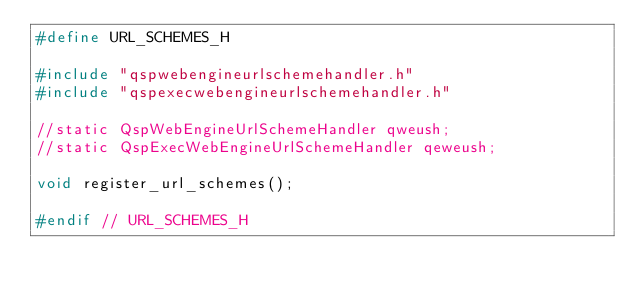<code> <loc_0><loc_0><loc_500><loc_500><_C_>#define URL_SCHEMES_H

#include "qspwebengineurlschemehandler.h"
#include "qspexecwebengineurlschemehandler.h"

//static QspWebEngineUrlSchemeHandler qweush;
//static QspExecWebEngineUrlSchemeHandler qeweush;

void register_url_schemes();

#endif // URL_SCHEMES_H
</code> 